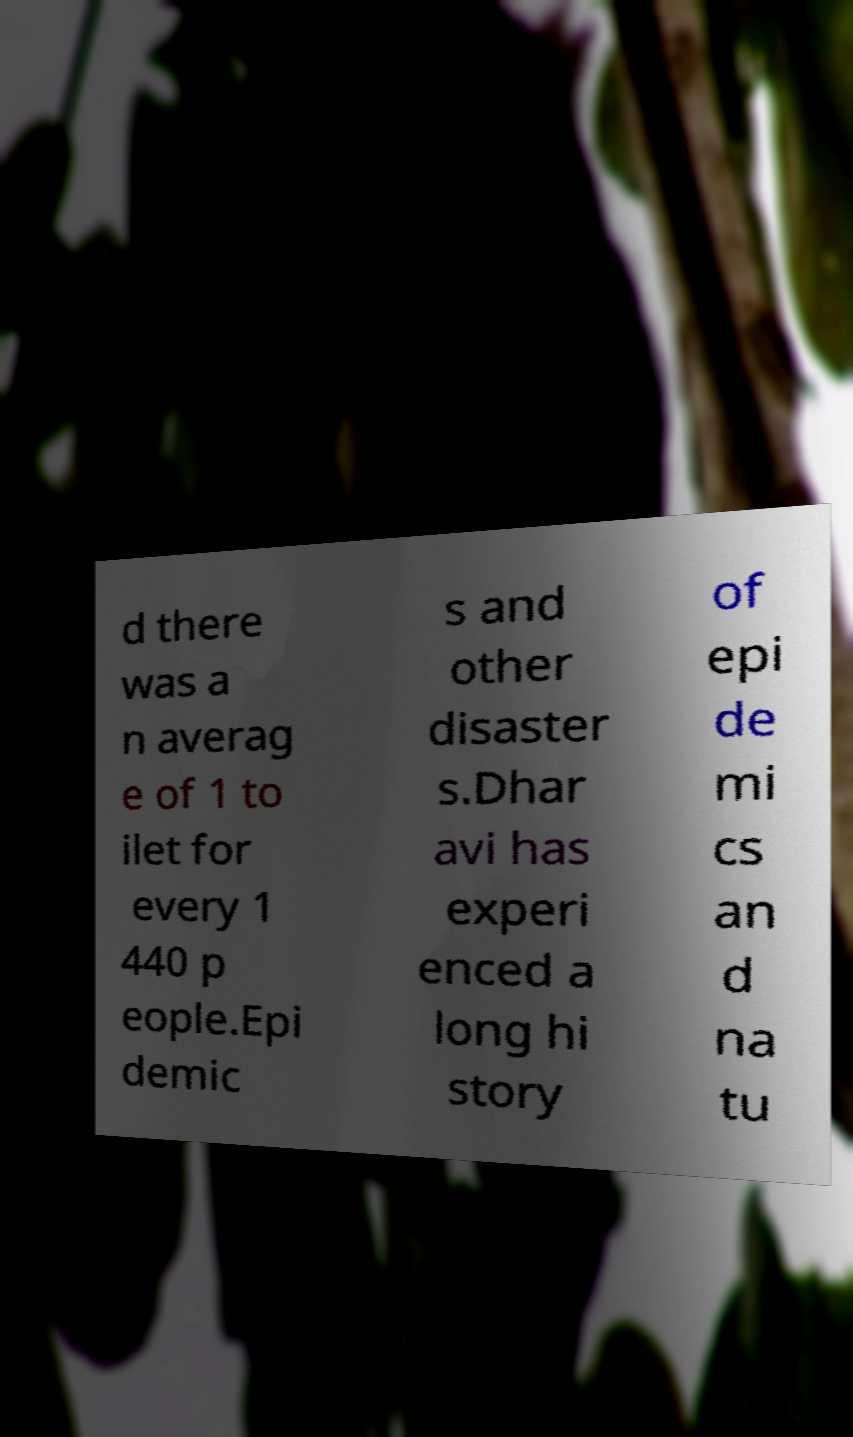Please read and relay the text visible in this image. What does it say? d there was a n averag e of 1 to ilet for every 1 440 p eople.Epi demic s and other disaster s.Dhar avi has experi enced a long hi story of epi de mi cs an d na tu 